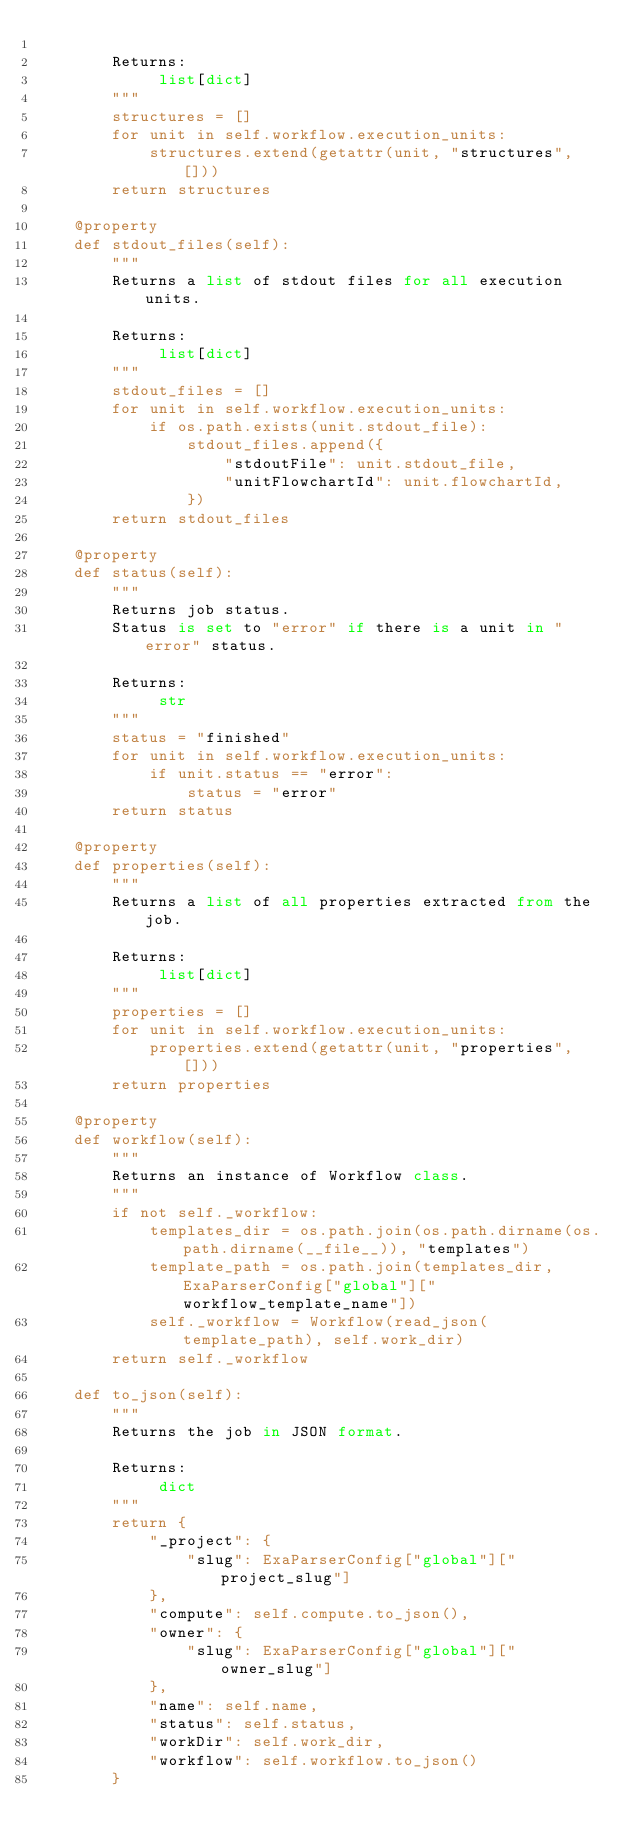<code> <loc_0><loc_0><loc_500><loc_500><_Python_>
        Returns:
             list[dict]
        """
        structures = []
        for unit in self.workflow.execution_units:
            structures.extend(getattr(unit, "structures", []))
        return structures

    @property
    def stdout_files(self):
        """
        Returns a list of stdout files for all execution units.

        Returns:
             list[dict]
        """
        stdout_files = []
        for unit in self.workflow.execution_units:
            if os.path.exists(unit.stdout_file):
                stdout_files.append({
                    "stdoutFile": unit.stdout_file,
                    "unitFlowchartId": unit.flowchartId,
                })
        return stdout_files

    @property
    def status(self):
        """
        Returns job status.
        Status is set to "error" if there is a unit in "error" status.

        Returns:
             str
        """
        status = "finished"
        for unit in self.workflow.execution_units:
            if unit.status == "error":
                status = "error"
        return status

    @property
    def properties(self):
        """
        Returns a list of all properties extracted from the job.

        Returns:
             list[dict]
        """
        properties = []
        for unit in self.workflow.execution_units:
            properties.extend(getattr(unit, "properties", []))
        return properties

    @property
    def workflow(self):
        """
        Returns an instance of Workflow class.
        """
        if not self._workflow:
            templates_dir = os.path.join(os.path.dirname(os.path.dirname(__file__)), "templates")
            template_path = os.path.join(templates_dir, ExaParserConfig["global"]["workflow_template_name"])
            self._workflow = Workflow(read_json(template_path), self.work_dir)
        return self._workflow

    def to_json(self):
        """
        Returns the job in JSON format.

        Returns:
             dict
        """
        return {
            "_project": {
                "slug": ExaParserConfig["global"]["project_slug"]
            },
            "compute": self.compute.to_json(),
            "owner": {
                "slug": ExaParserConfig["global"]["owner_slug"]
            },
            "name": self.name,
            "status": self.status,
            "workDir": self.work_dir,
            "workflow": self.workflow.to_json()
        }
</code> 